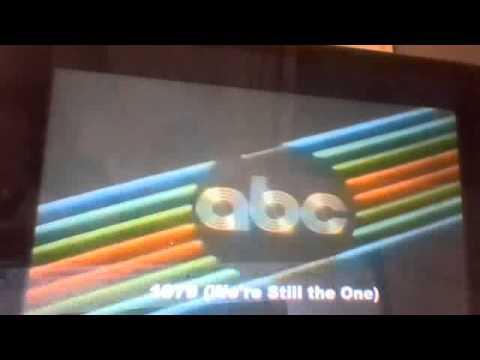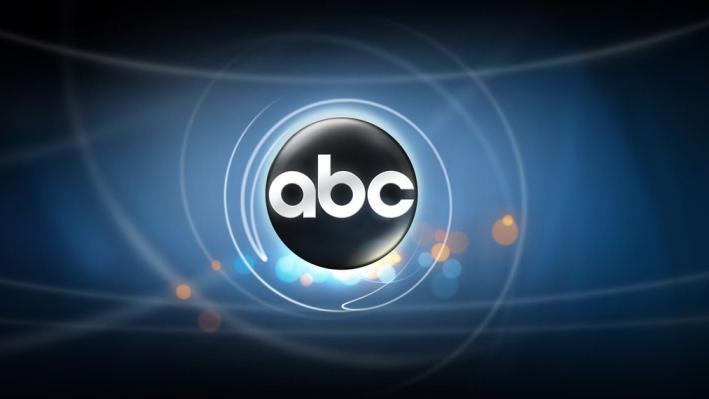The first image is the image on the left, the second image is the image on the right. Examine the images to the left and right. Is the description "In the image to the right the golfball has a design that is square shaped." accurate? Answer yes or no. No. 